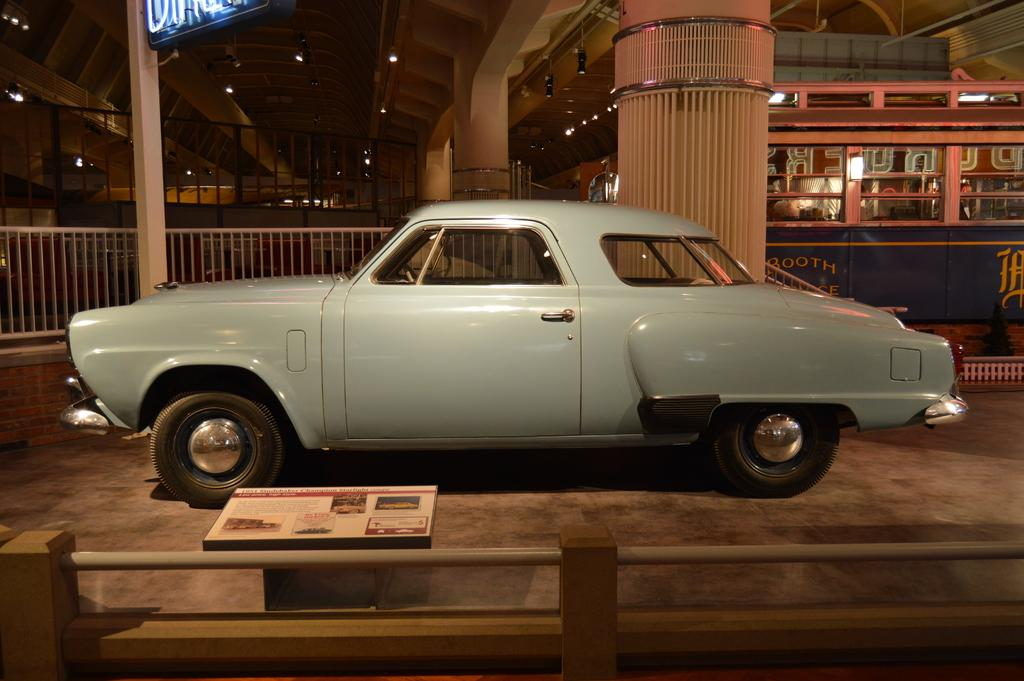What is the main subject in the center of the image? There is a car in the center of the image. What can be seen at the bottom of the image? There is a fence and a board at the bottom of the image. What is visible in the background of the image? There is a bus, pillars, and a grill in the background of the image. What is present at the top of the image? There are lights at the top of the image. What shape does the force of destruction take in the image? There is no force of destruction present in the image, so it is not possible to determine its shape. 